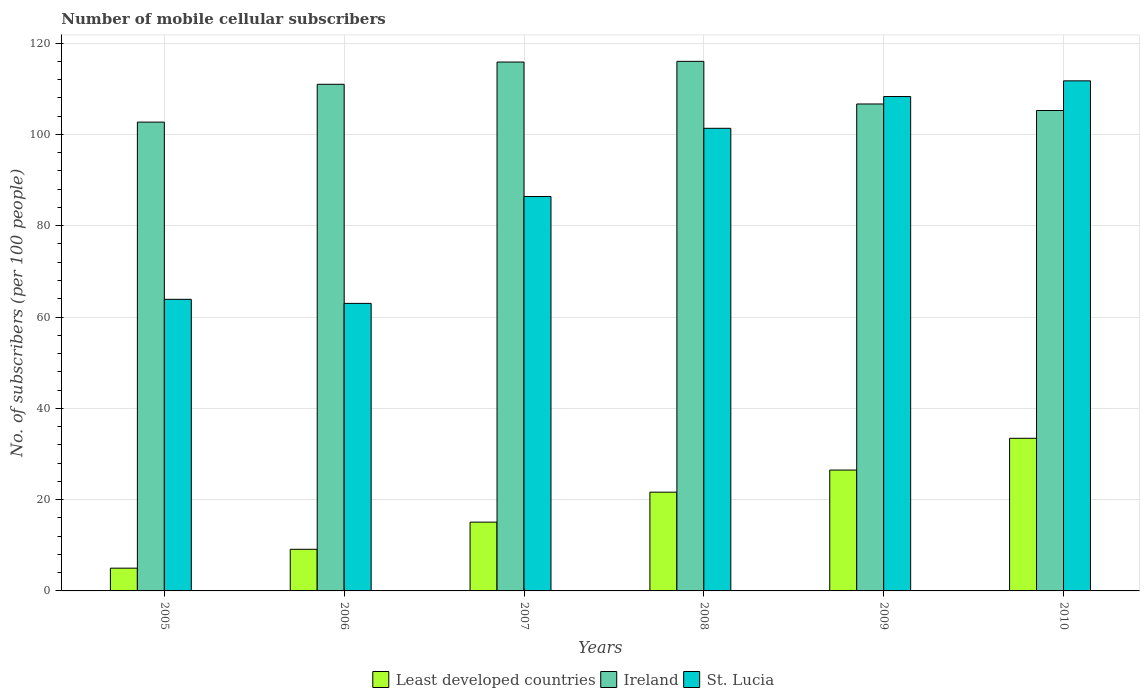How many groups of bars are there?
Keep it short and to the point. 6. Are the number of bars per tick equal to the number of legend labels?
Your answer should be compact. Yes. Are the number of bars on each tick of the X-axis equal?
Give a very brief answer. Yes. What is the label of the 6th group of bars from the left?
Make the answer very short. 2010. What is the number of mobile cellular subscribers in Ireland in 2008?
Your response must be concise. 116. Across all years, what is the maximum number of mobile cellular subscribers in Ireland?
Provide a short and direct response. 116. Across all years, what is the minimum number of mobile cellular subscribers in Least developed countries?
Your answer should be compact. 4.98. In which year was the number of mobile cellular subscribers in Ireland minimum?
Offer a very short reply. 2005. What is the total number of mobile cellular subscribers in Ireland in the graph?
Your response must be concise. 657.43. What is the difference between the number of mobile cellular subscribers in Ireland in 2005 and that in 2010?
Your response must be concise. -2.54. What is the difference between the number of mobile cellular subscribers in Least developed countries in 2007 and the number of mobile cellular subscribers in St. Lucia in 2005?
Provide a succinct answer. -48.81. What is the average number of mobile cellular subscribers in St. Lucia per year?
Your response must be concise. 89.1. In the year 2006, what is the difference between the number of mobile cellular subscribers in Least developed countries and number of mobile cellular subscribers in Ireland?
Provide a succinct answer. -101.86. What is the ratio of the number of mobile cellular subscribers in St. Lucia in 2005 to that in 2007?
Make the answer very short. 0.74. Is the number of mobile cellular subscribers in Least developed countries in 2009 less than that in 2010?
Make the answer very short. Yes. What is the difference between the highest and the second highest number of mobile cellular subscribers in Ireland?
Provide a short and direct response. 0.15. What is the difference between the highest and the lowest number of mobile cellular subscribers in Least developed countries?
Offer a terse response. 28.45. What does the 2nd bar from the left in 2010 represents?
Your answer should be compact. Ireland. What does the 1st bar from the right in 2010 represents?
Your response must be concise. St. Lucia. Is it the case that in every year, the sum of the number of mobile cellular subscribers in Ireland and number of mobile cellular subscribers in St. Lucia is greater than the number of mobile cellular subscribers in Least developed countries?
Your answer should be compact. Yes. How many bars are there?
Keep it short and to the point. 18. Are the values on the major ticks of Y-axis written in scientific E-notation?
Give a very brief answer. No. Does the graph contain any zero values?
Your answer should be very brief. No. Does the graph contain grids?
Provide a short and direct response. Yes. Where does the legend appear in the graph?
Your response must be concise. Bottom center. How many legend labels are there?
Give a very brief answer. 3. What is the title of the graph?
Your answer should be compact. Number of mobile cellular subscribers. Does "Thailand" appear as one of the legend labels in the graph?
Make the answer very short. No. What is the label or title of the Y-axis?
Provide a succinct answer. No. of subscribers (per 100 people). What is the No. of subscribers (per 100 people) in Least developed countries in 2005?
Make the answer very short. 4.98. What is the No. of subscribers (per 100 people) in Ireland in 2005?
Provide a short and direct response. 102.69. What is the No. of subscribers (per 100 people) in St. Lucia in 2005?
Offer a terse response. 63.88. What is the No. of subscribers (per 100 people) in Least developed countries in 2006?
Your response must be concise. 9.12. What is the No. of subscribers (per 100 people) in Ireland in 2006?
Offer a terse response. 110.98. What is the No. of subscribers (per 100 people) in St. Lucia in 2006?
Keep it short and to the point. 62.99. What is the No. of subscribers (per 100 people) of Least developed countries in 2007?
Make the answer very short. 15.07. What is the No. of subscribers (per 100 people) of Ireland in 2007?
Offer a terse response. 115.85. What is the No. of subscribers (per 100 people) in St. Lucia in 2007?
Your answer should be compact. 86.39. What is the No. of subscribers (per 100 people) of Least developed countries in 2008?
Keep it short and to the point. 21.63. What is the No. of subscribers (per 100 people) of Ireland in 2008?
Your answer should be very brief. 116. What is the No. of subscribers (per 100 people) in St. Lucia in 2008?
Your answer should be very brief. 101.34. What is the No. of subscribers (per 100 people) in Least developed countries in 2009?
Give a very brief answer. 26.48. What is the No. of subscribers (per 100 people) in Ireland in 2009?
Make the answer very short. 106.67. What is the No. of subscribers (per 100 people) in St. Lucia in 2009?
Your answer should be compact. 108.3. What is the No. of subscribers (per 100 people) in Least developed countries in 2010?
Offer a terse response. 33.43. What is the No. of subscribers (per 100 people) in Ireland in 2010?
Make the answer very short. 105.24. What is the No. of subscribers (per 100 people) of St. Lucia in 2010?
Offer a terse response. 111.73. Across all years, what is the maximum No. of subscribers (per 100 people) of Least developed countries?
Ensure brevity in your answer.  33.43. Across all years, what is the maximum No. of subscribers (per 100 people) in Ireland?
Offer a very short reply. 116. Across all years, what is the maximum No. of subscribers (per 100 people) of St. Lucia?
Provide a short and direct response. 111.73. Across all years, what is the minimum No. of subscribers (per 100 people) in Least developed countries?
Give a very brief answer. 4.98. Across all years, what is the minimum No. of subscribers (per 100 people) in Ireland?
Provide a short and direct response. 102.69. Across all years, what is the minimum No. of subscribers (per 100 people) in St. Lucia?
Offer a very short reply. 62.99. What is the total No. of subscribers (per 100 people) in Least developed countries in the graph?
Offer a very short reply. 110.72. What is the total No. of subscribers (per 100 people) of Ireland in the graph?
Provide a succinct answer. 657.43. What is the total No. of subscribers (per 100 people) of St. Lucia in the graph?
Keep it short and to the point. 534.63. What is the difference between the No. of subscribers (per 100 people) in Least developed countries in 2005 and that in 2006?
Provide a succinct answer. -4.14. What is the difference between the No. of subscribers (per 100 people) of Ireland in 2005 and that in 2006?
Ensure brevity in your answer.  -8.29. What is the difference between the No. of subscribers (per 100 people) in St. Lucia in 2005 and that in 2006?
Ensure brevity in your answer.  0.89. What is the difference between the No. of subscribers (per 100 people) of Least developed countries in 2005 and that in 2007?
Your answer should be compact. -10.08. What is the difference between the No. of subscribers (per 100 people) of Ireland in 2005 and that in 2007?
Make the answer very short. -13.16. What is the difference between the No. of subscribers (per 100 people) in St. Lucia in 2005 and that in 2007?
Keep it short and to the point. -22.52. What is the difference between the No. of subscribers (per 100 people) of Least developed countries in 2005 and that in 2008?
Your response must be concise. -16.65. What is the difference between the No. of subscribers (per 100 people) of Ireland in 2005 and that in 2008?
Provide a short and direct response. -13.31. What is the difference between the No. of subscribers (per 100 people) of St. Lucia in 2005 and that in 2008?
Provide a short and direct response. -37.46. What is the difference between the No. of subscribers (per 100 people) in Least developed countries in 2005 and that in 2009?
Make the answer very short. -21.49. What is the difference between the No. of subscribers (per 100 people) in Ireland in 2005 and that in 2009?
Ensure brevity in your answer.  -3.97. What is the difference between the No. of subscribers (per 100 people) in St. Lucia in 2005 and that in 2009?
Offer a terse response. -44.42. What is the difference between the No. of subscribers (per 100 people) of Least developed countries in 2005 and that in 2010?
Give a very brief answer. -28.45. What is the difference between the No. of subscribers (per 100 people) of Ireland in 2005 and that in 2010?
Keep it short and to the point. -2.54. What is the difference between the No. of subscribers (per 100 people) of St. Lucia in 2005 and that in 2010?
Your answer should be compact. -47.86. What is the difference between the No. of subscribers (per 100 people) in Least developed countries in 2006 and that in 2007?
Make the answer very short. -5.95. What is the difference between the No. of subscribers (per 100 people) in Ireland in 2006 and that in 2007?
Your response must be concise. -4.87. What is the difference between the No. of subscribers (per 100 people) of St. Lucia in 2006 and that in 2007?
Keep it short and to the point. -23.41. What is the difference between the No. of subscribers (per 100 people) of Least developed countries in 2006 and that in 2008?
Your answer should be very brief. -12.51. What is the difference between the No. of subscribers (per 100 people) of Ireland in 2006 and that in 2008?
Give a very brief answer. -5.02. What is the difference between the No. of subscribers (per 100 people) in St. Lucia in 2006 and that in 2008?
Ensure brevity in your answer.  -38.35. What is the difference between the No. of subscribers (per 100 people) in Least developed countries in 2006 and that in 2009?
Provide a succinct answer. -17.35. What is the difference between the No. of subscribers (per 100 people) in Ireland in 2006 and that in 2009?
Your answer should be compact. 4.31. What is the difference between the No. of subscribers (per 100 people) in St. Lucia in 2006 and that in 2009?
Give a very brief answer. -45.31. What is the difference between the No. of subscribers (per 100 people) of Least developed countries in 2006 and that in 2010?
Your response must be concise. -24.31. What is the difference between the No. of subscribers (per 100 people) of Ireland in 2006 and that in 2010?
Give a very brief answer. 5.74. What is the difference between the No. of subscribers (per 100 people) of St. Lucia in 2006 and that in 2010?
Your answer should be compact. -48.75. What is the difference between the No. of subscribers (per 100 people) in Least developed countries in 2007 and that in 2008?
Provide a succinct answer. -6.57. What is the difference between the No. of subscribers (per 100 people) in Ireland in 2007 and that in 2008?
Ensure brevity in your answer.  -0.15. What is the difference between the No. of subscribers (per 100 people) in St. Lucia in 2007 and that in 2008?
Offer a terse response. -14.94. What is the difference between the No. of subscribers (per 100 people) of Least developed countries in 2007 and that in 2009?
Offer a very short reply. -11.41. What is the difference between the No. of subscribers (per 100 people) of Ireland in 2007 and that in 2009?
Provide a short and direct response. 9.19. What is the difference between the No. of subscribers (per 100 people) in St. Lucia in 2007 and that in 2009?
Your answer should be very brief. -21.9. What is the difference between the No. of subscribers (per 100 people) of Least developed countries in 2007 and that in 2010?
Provide a succinct answer. -18.37. What is the difference between the No. of subscribers (per 100 people) of Ireland in 2007 and that in 2010?
Your answer should be very brief. 10.62. What is the difference between the No. of subscribers (per 100 people) of St. Lucia in 2007 and that in 2010?
Provide a short and direct response. -25.34. What is the difference between the No. of subscribers (per 100 people) in Least developed countries in 2008 and that in 2009?
Offer a terse response. -4.84. What is the difference between the No. of subscribers (per 100 people) in Ireland in 2008 and that in 2009?
Offer a terse response. 9.34. What is the difference between the No. of subscribers (per 100 people) of St. Lucia in 2008 and that in 2009?
Provide a succinct answer. -6.96. What is the difference between the No. of subscribers (per 100 people) of Least developed countries in 2008 and that in 2010?
Offer a very short reply. -11.8. What is the difference between the No. of subscribers (per 100 people) of Ireland in 2008 and that in 2010?
Offer a terse response. 10.77. What is the difference between the No. of subscribers (per 100 people) in St. Lucia in 2008 and that in 2010?
Your answer should be very brief. -10.4. What is the difference between the No. of subscribers (per 100 people) of Least developed countries in 2009 and that in 2010?
Offer a very short reply. -6.96. What is the difference between the No. of subscribers (per 100 people) in Ireland in 2009 and that in 2010?
Give a very brief answer. 1.43. What is the difference between the No. of subscribers (per 100 people) in St. Lucia in 2009 and that in 2010?
Offer a very short reply. -3.44. What is the difference between the No. of subscribers (per 100 people) of Least developed countries in 2005 and the No. of subscribers (per 100 people) of Ireland in 2006?
Your answer should be very brief. -106. What is the difference between the No. of subscribers (per 100 people) in Least developed countries in 2005 and the No. of subscribers (per 100 people) in St. Lucia in 2006?
Provide a succinct answer. -58. What is the difference between the No. of subscribers (per 100 people) of Ireland in 2005 and the No. of subscribers (per 100 people) of St. Lucia in 2006?
Keep it short and to the point. 39.71. What is the difference between the No. of subscribers (per 100 people) in Least developed countries in 2005 and the No. of subscribers (per 100 people) in Ireland in 2007?
Your answer should be compact. -110.87. What is the difference between the No. of subscribers (per 100 people) of Least developed countries in 2005 and the No. of subscribers (per 100 people) of St. Lucia in 2007?
Provide a succinct answer. -81.41. What is the difference between the No. of subscribers (per 100 people) in Ireland in 2005 and the No. of subscribers (per 100 people) in St. Lucia in 2007?
Your answer should be compact. 16.3. What is the difference between the No. of subscribers (per 100 people) of Least developed countries in 2005 and the No. of subscribers (per 100 people) of Ireland in 2008?
Keep it short and to the point. -111.02. What is the difference between the No. of subscribers (per 100 people) in Least developed countries in 2005 and the No. of subscribers (per 100 people) in St. Lucia in 2008?
Provide a succinct answer. -96.35. What is the difference between the No. of subscribers (per 100 people) in Ireland in 2005 and the No. of subscribers (per 100 people) in St. Lucia in 2008?
Ensure brevity in your answer.  1.36. What is the difference between the No. of subscribers (per 100 people) in Least developed countries in 2005 and the No. of subscribers (per 100 people) in Ireland in 2009?
Ensure brevity in your answer.  -101.68. What is the difference between the No. of subscribers (per 100 people) of Least developed countries in 2005 and the No. of subscribers (per 100 people) of St. Lucia in 2009?
Ensure brevity in your answer.  -103.31. What is the difference between the No. of subscribers (per 100 people) in Ireland in 2005 and the No. of subscribers (per 100 people) in St. Lucia in 2009?
Your answer should be compact. -5.6. What is the difference between the No. of subscribers (per 100 people) of Least developed countries in 2005 and the No. of subscribers (per 100 people) of Ireland in 2010?
Offer a terse response. -100.25. What is the difference between the No. of subscribers (per 100 people) of Least developed countries in 2005 and the No. of subscribers (per 100 people) of St. Lucia in 2010?
Your answer should be compact. -106.75. What is the difference between the No. of subscribers (per 100 people) in Ireland in 2005 and the No. of subscribers (per 100 people) in St. Lucia in 2010?
Your answer should be very brief. -9.04. What is the difference between the No. of subscribers (per 100 people) in Least developed countries in 2006 and the No. of subscribers (per 100 people) in Ireland in 2007?
Your answer should be compact. -106.73. What is the difference between the No. of subscribers (per 100 people) of Least developed countries in 2006 and the No. of subscribers (per 100 people) of St. Lucia in 2007?
Ensure brevity in your answer.  -77.27. What is the difference between the No. of subscribers (per 100 people) of Ireland in 2006 and the No. of subscribers (per 100 people) of St. Lucia in 2007?
Make the answer very short. 24.59. What is the difference between the No. of subscribers (per 100 people) of Least developed countries in 2006 and the No. of subscribers (per 100 people) of Ireland in 2008?
Offer a very short reply. -106.88. What is the difference between the No. of subscribers (per 100 people) of Least developed countries in 2006 and the No. of subscribers (per 100 people) of St. Lucia in 2008?
Your answer should be very brief. -92.22. What is the difference between the No. of subscribers (per 100 people) in Ireland in 2006 and the No. of subscribers (per 100 people) in St. Lucia in 2008?
Give a very brief answer. 9.64. What is the difference between the No. of subscribers (per 100 people) in Least developed countries in 2006 and the No. of subscribers (per 100 people) in Ireland in 2009?
Give a very brief answer. -97.55. What is the difference between the No. of subscribers (per 100 people) in Least developed countries in 2006 and the No. of subscribers (per 100 people) in St. Lucia in 2009?
Your answer should be compact. -99.18. What is the difference between the No. of subscribers (per 100 people) of Ireland in 2006 and the No. of subscribers (per 100 people) of St. Lucia in 2009?
Your answer should be compact. 2.68. What is the difference between the No. of subscribers (per 100 people) in Least developed countries in 2006 and the No. of subscribers (per 100 people) in Ireland in 2010?
Your answer should be very brief. -96.11. What is the difference between the No. of subscribers (per 100 people) of Least developed countries in 2006 and the No. of subscribers (per 100 people) of St. Lucia in 2010?
Keep it short and to the point. -102.61. What is the difference between the No. of subscribers (per 100 people) in Ireland in 2006 and the No. of subscribers (per 100 people) in St. Lucia in 2010?
Make the answer very short. -0.75. What is the difference between the No. of subscribers (per 100 people) in Least developed countries in 2007 and the No. of subscribers (per 100 people) in Ireland in 2008?
Provide a short and direct response. -100.94. What is the difference between the No. of subscribers (per 100 people) of Least developed countries in 2007 and the No. of subscribers (per 100 people) of St. Lucia in 2008?
Offer a very short reply. -86.27. What is the difference between the No. of subscribers (per 100 people) of Ireland in 2007 and the No. of subscribers (per 100 people) of St. Lucia in 2008?
Keep it short and to the point. 14.52. What is the difference between the No. of subscribers (per 100 people) of Least developed countries in 2007 and the No. of subscribers (per 100 people) of Ireland in 2009?
Make the answer very short. -91.6. What is the difference between the No. of subscribers (per 100 people) in Least developed countries in 2007 and the No. of subscribers (per 100 people) in St. Lucia in 2009?
Make the answer very short. -93.23. What is the difference between the No. of subscribers (per 100 people) in Ireland in 2007 and the No. of subscribers (per 100 people) in St. Lucia in 2009?
Your answer should be very brief. 7.56. What is the difference between the No. of subscribers (per 100 people) of Least developed countries in 2007 and the No. of subscribers (per 100 people) of Ireland in 2010?
Provide a short and direct response. -90.17. What is the difference between the No. of subscribers (per 100 people) in Least developed countries in 2007 and the No. of subscribers (per 100 people) in St. Lucia in 2010?
Provide a succinct answer. -96.67. What is the difference between the No. of subscribers (per 100 people) in Ireland in 2007 and the No. of subscribers (per 100 people) in St. Lucia in 2010?
Your response must be concise. 4.12. What is the difference between the No. of subscribers (per 100 people) of Least developed countries in 2008 and the No. of subscribers (per 100 people) of Ireland in 2009?
Provide a short and direct response. -85.03. What is the difference between the No. of subscribers (per 100 people) in Least developed countries in 2008 and the No. of subscribers (per 100 people) in St. Lucia in 2009?
Provide a short and direct response. -86.66. What is the difference between the No. of subscribers (per 100 people) of Ireland in 2008 and the No. of subscribers (per 100 people) of St. Lucia in 2009?
Your response must be concise. 7.71. What is the difference between the No. of subscribers (per 100 people) of Least developed countries in 2008 and the No. of subscribers (per 100 people) of Ireland in 2010?
Provide a short and direct response. -83.6. What is the difference between the No. of subscribers (per 100 people) of Least developed countries in 2008 and the No. of subscribers (per 100 people) of St. Lucia in 2010?
Offer a very short reply. -90.1. What is the difference between the No. of subscribers (per 100 people) in Ireland in 2008 and the No. of subscribers (per 100 people) in St. Lucia in 2010?
Offer a very short reply. 4.27. What is the difference between the No. of subscribers (per 100 people) in Least developed countries in 2009 and the No. of subscribers (per 100 people) in Ireland in 2010?
Offer a very short reply. -78.76. What is the difference between the No. of subscribers (per 100 people) of Least developed countries in 2009 and the No. of subscribers (per 100 people) of St. Lucia in 2010?
Your answer should be compact. -85.26. What is the difference between the No. of subscribers (per 100 people) in Ireland in 2009 and the No. of subscribers (per 100 people) in St. Lucia in 2010?
Make the answer very short. -5.07. What is the average No. of subscribers (per 100 people) in Least developed countries per year?
Provide a short and direct response. 18.45. What is the average No. of subscribers (per 100 people) in Ireland per year?
Make the answer very short. 109.57. What is the average No. of subscribers (per 100 people) in St. Lucia per year?
Make the answer very short. 89.1. In the year 2005, what is the difference between the No. of subscribers (per 100 people) of Least developed countries and No. of subscribers (per 100 people) of Ireland?
Ensure brevity in your answer.  -97.71. In the year 2005, what is the difference between the No. of subscribers (per 100 people) of Least developed countries and No. of subscribers (per 100 people) of St. Lucia?
Your response must be concise. -58.89. In the year 2005, what is the difference between the No. of subscribers (per 100 people) of Ireland and No. of subscribers (per 100 people) of St. Lucia?
Your response must be concise. 38.82. In the year 2006, what is the difference between the No. of subscribers (per 100 people) in Least developed countries and No. of subscribers (per 100 people) in Ireland?
Make the answer very short. -101.86. In the year 2006, what is the difference between the No. of subscribers (per 100 people) in Least developed countries and No. of subscribers (per 100 people) in St. Lucia?
Offer a very short reply. -53.86. In the year 2006, what is the difference between the No. of subscribers (per 100 people) of Ireland and No. of subscribers (per 100 people) of St. Lucia?
Your answer should be compact. 47.99. In the year 2007, what is the difference between the No. of subscribers (per 100 people) in Least developed countries and No. of subscribers (per 100 people) in Ireland?
Your answer should be compact. -100.79. In the year 2007, what is the difference between the No. of subscribers (per 100 people) in Least developed countries and No. of subscribers (per 100 people) in St. Lucia?
Offer a terse response. -71.33. In the year 2007, what is the difference between the No. of subscribers (per 100 people) in Ireland and No. of subscribers (per 100 people) in St. Lucia?
Offer a terse response. 29.46. In the year 2008, what is the difference between the No. of subscribers (per 100 people) in Least developed countries and No. of subscribers (per 100 people) in Ireland?
Keep it short and to the point. -94.37. In the year 2008, what is the difference between the No. of subscribers (per 100 people) of Least developed countries and No. of subscribers (per 100 people) of St. Lucia?
Your answer should be very brief. -79.7. In the year 2008, what is the difference between the No. of subscribers (per 100 people) in Ireland and No. of subscribers (per 100 people) in St. Lucia?
Your answer should be compact. 14.67. In the year 2009, what is the difference between the No. of subscribers (per 100 people) of Least developed countries and No. of subscribers (per 100 people) of Ireland?
Provide a succinct answer. -80.19. In the year 2009, what is the difference between the No. of subscribers (per 100 people) of Least developed countries and No. of subscribers (per 100 people) of St. Lucia?
Your answer should be very brief. -81.82. In the year 2009, what is the difference between the No. of subscribers (per 100 people) of Ireland and No. of subscribers (per 100 people) of St. Lucia?
Ensure brevity in your answer.  -1.63. In the year 2010, what is the difference between the No. of subscribers (per 100 people) of Least developed countries and No. of subscribers (per 100 people) of Ireland?
Provide a short and direct response. -71.8. In the year 2010, what is the difference between the No. of subscribers (per 100 people) of Least developed countries and No. of subscribers (per 100 people) of St. Lucia?
Your answer should be compact. -78.3. In the year 2010, what is the difference between the No. of subscribers (per 100 people) of Ireland and No. of subscribers (per 100 people) of St. Lucia?
Offer a very short reply. -6.5. What is the ratio of the No. of subscribers (per 100 people) of Least developed countries in 2005 to that in 2006?
Your response must be concise. 0.55. What is the ratio of the No. of subscribers (per 100 people) in Ireland in 2005 to that in 2006?
Provide a succinct answer. 0.93. What is the ratio of the No. of subscribers (per 100 people) in St. Lucia in 2005 to that in 2006?
Offer a terse response. 1.01. What is the ratio of the No. of subscribers (per 100 people) in Least developed countries in 2005 to that in 2007?
Keep it short and to the point. 0.33. What is the ratio of the No. of subscribers (per 100 people) of Ireland in 2005 to that in 2007?
Your answer should be very brief. 0.89. What is the ratio of the No. of subscribers (per 100 people) in St. Lucia in 2005 to that in 2007?
Provide a short and direct response. 0.74. What is the ratio of the No. of subscribers (per 100 people) of Least developed countries in 2005 to that in 2008?
Give a very brief answer. 0.23. What is the ratio of the No. of subscribers (per 100 people) of Ireland in 2005 to that in 2008?
Offer a very short reply. 0.89. What is the ratio of the No. of subscribers (per 100 people) in St. Lucia in 2005 to that in 2008?
Make the answer very short. 0.63. What is the ratio of the No. of subscribers (per 100 people) of Least developed countries in 2005 to that in 2009?
Ensure brevity in your answer.  0.19. What is the ratio of the No. of subscribers (per 100 people) in Ireland in 2005 to that in 2009?
Your response must be concise. 0.96. What is the ratio of the No. of subscribers (per 100 people) in St. Lucia in 2005 to that in 2009?
Keep it short and to the point. 0.59. What is the ratio of the No. of subscribers (per 100 people) in Least developed countries in 2005 to that in 2010?
Provide a short and direct response. 0.15. What is the ratio of the No. of subscribers (per 100 people) of Ireland in 2005 to that in 2010?
Ensure brevity in your answer.  0.98. What is the ratio of the No. of subscribers (per 100 people) of St. Lucia in 2005 to that in 2010?
Your answer should be very brief. 0.57. What is the ratio of the No. of subscribers (per 100 people) in Least developed countries in 2006 to that in 2007?
Offer a terse response. 0.61. What is the ratio of the No. of subscribers (per 100 people) in Ireland in 2006 to that in 2007?
Your response must be concise. 0.96. What is the ratio of the No. of subscribers (per 100 people) of St. Lucia in 2006 to that in 2007?
Provide a succinct answer. 0.73. What is the ratio of the No. of subscribers (per 100 people) of Least developed countries in 2006 to that in 2008?
Your answer should be compact. 0.42. What is the ratio of the No. of subscribers (per 100 people) of Ireland in 2006 to that in 2008?
Provide a succinct answer. 0.96. What is the ratio of the No. of subscribers (per 100 people) in St. Lucia in 2006 to that in 2008?
Ensure brevity in your answer.  0.62. What is the ratio of the No. of subscribers (per 100 people) of Least developed countries in 2006 to that in 2009?
Provide a succinct answer. 0.34. What is the ratio of the No. of subscribers (per 100 people) in Ireland in 2006 to that in 2009?
Provide a short and direct response. 1.04. What is the ratio of the No. of subscribers (per 100 people) in St. Lucia in 2006 to that in 2009?
Offer a terse response. 0.58. What is the ratio of the No. of subscribers (per 100 people) in Least developed countries in 2006 to that in 2010?
Give a very brief answer. 0.27. What is the ratio of the No. of subscribers (per 100 people) in Ireland in 2006 to that in 2010?
Offer a very short reply. 1.05. What is the ratio of the No. of subscribers (per 100 people) of St. Lucia in 2006 to that in 2010?
Your answer should be very brief. 0.56. What is the ratio of the No. of subscribers (per 100 people) in Least developed countries in 2007 to that in 2008?
Provide a short and direct response. 0.7. What is the ratio of the No. of subscribers (per 100 people) in St. Lucia in 2007 to that in 2008?
Make the answer very short. 0.85. What is the ratio of the No. of subscribers (per 100 people) in Least developed countries in 2007 to that in 2009?
Provide a succinct answer. 0.57. What is the ratio of the No. of subscribers (per 100 people) of Ireland in 2007 to that in 2009?
Offer a very short reply. 1.09. What is the ratio of the No. of subscribers (per 100 people) in St. Lucia in 2007 to that in 2009?
Keep it short and to the point. 0.8. What is the ratio of the No. of subscribers (per 100 people) of Least developed countries in 2007 to that in 2010?
Provide a short and direct response. 0.45. What is the ratio of the No. of subscribers (per 100 people) in Ireland in 2007 to that in 2010?
Your answer should be compact. 1.1. What is the ratio of the No. of subscribers (per 100 people) of St. Lucia in 2007 to that in 2010?
Give a very brief answer. 0.77. What is the ratio of the No. of subscribers (per 100 people) of Least developed countries in 2008 to that in 2009?
Keep it short and to the point. 0.82. What is the ratio of the No. of subscribers (per 100 people) of Ireland in 2008 to that in 2009?
Offer a terse response. 1.09. What is the ratio of the No. of subscribers (per 100 people) in St. Lucia in 2008 to that in 2009?
Give a very brief answer. 0.94. What is the ratio of the No. of subscribers (per 100 people) of Least developed countries in 2008 to that in 2010?
Offer a terse response. 0.65. What is the ratio of the No. of subscribers (per 100 people) in Ireland in 2008 to that in 2010?
Provide a succinct answer. 1.1. What is the ratio of the No. of subscribers (per 100 people) of St. Lucia in 2008 to that in 2010?
Your response must be concise. 0.91. What is the ratio of the No. of subscribers (per 100 people) in Least developed countries in 2009 to that in 2010?
Offer a very short reply. 0.79. What is the ratio of the No. of subscribers (per 100 people) of Ireland in 2009 to that in 2010?
Provide a succinct answer. 1.01. What is the ratio of the No. of subscribers (per 100 people) of St. Lucia in 2009 to that in 2010?
Offer a very short reply. 0.97. What is the difference between the highest and the second highest No. of subscribers (per 100 people) in Least developed countries?
Provide a succinct answer. 6.96. What is the difference between the highest and the second highest No. of subscribers (per 100 people) in Ireland?
Keep it short and to the point. 0.15. What is the difference between the highest and the second highest No. of subscribers (per 100 people) of St. Lucia?
Your answer should be compact. 3.44. What is the difference between the highest and the lowest No. of subscribers (per 100 people) of Least developed countries?
Give a very brief answer. 28.45. What is the difference between the highest and the lowest No. of subscribers (per 100 people) in Ireland?
Provide a succinct answer. 13.31. What is the difference between the highest and the lowest No. of subscribers (per 100 people) of St. Lucia?
Offer a very short reply. 48.75. 